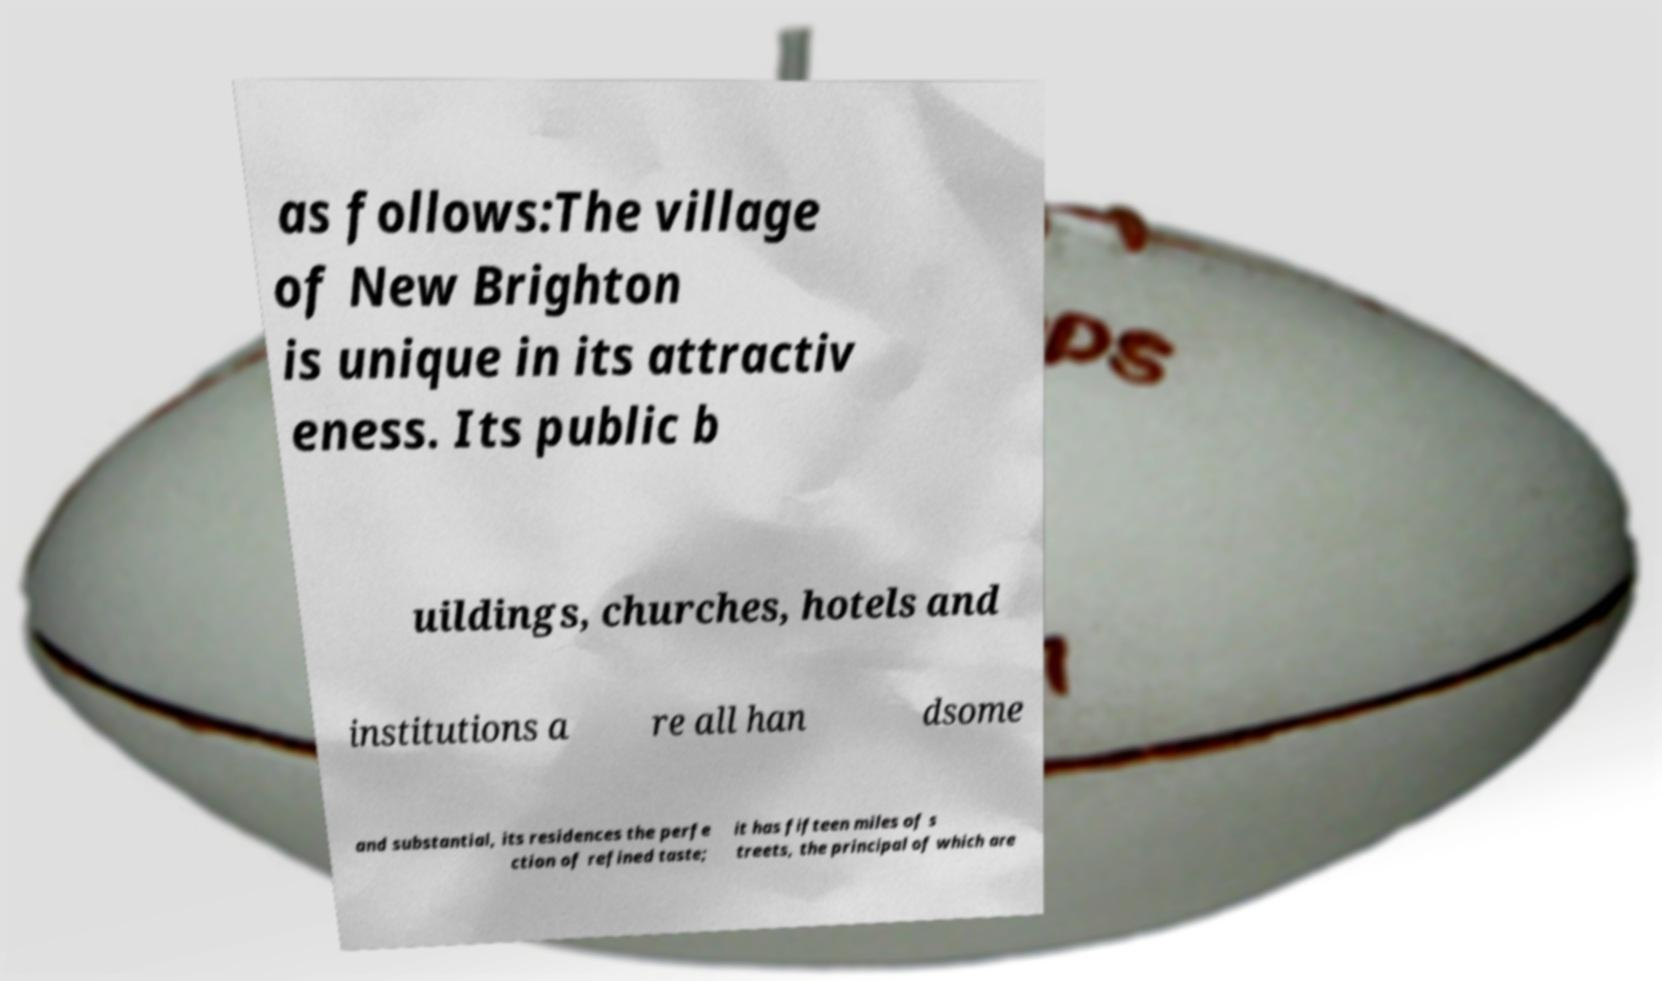Can you read and provide the text displayed in the image?This photo seems to have some interesting text. Can you extract and type it out for me? as follows:The village of New Brighton is unique in its attractiv eness. Its public b uildings, churches, hotels and institutions a re all han dsome and substantial, its residences the perfe ction of refined taste; it has fifteen miles of s treets, the principal of which are 